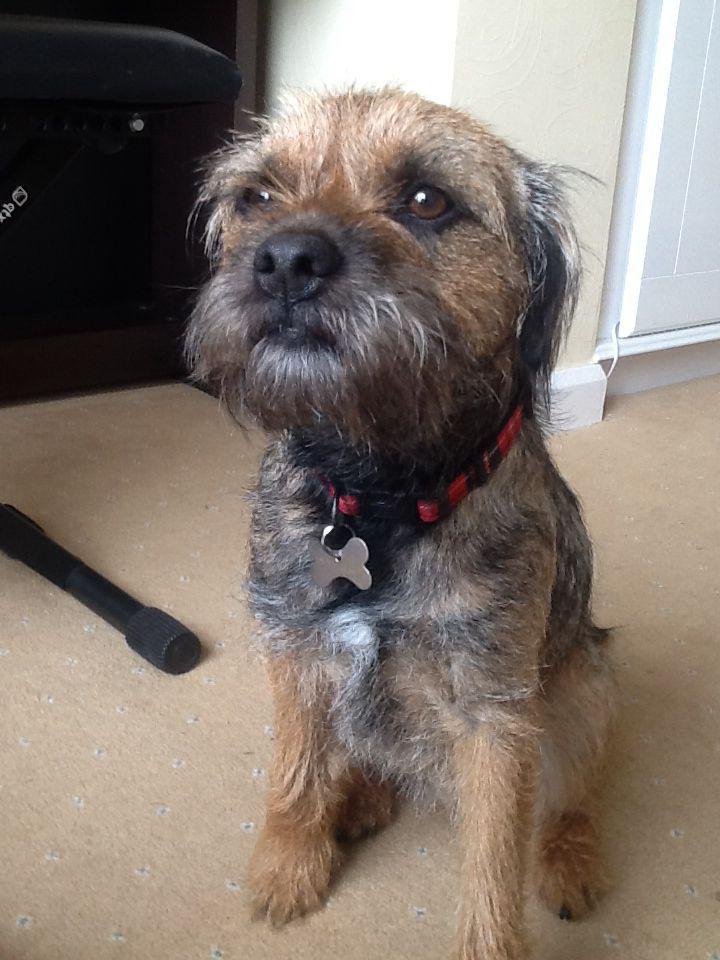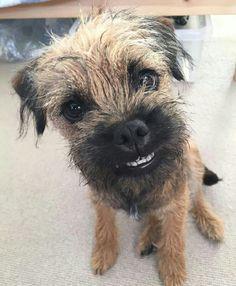The first image is the image on the left, the second image is the image on the right. For the images shown, is this caption "The dog in the image on the left is wearing a red collar." true? Answer yes or no. Yes. The first image is the image on the left, the second image is the image on the right. Assess this claim about the two images: "The dog on the left wears a red collar, and the dog on the right looks forward with a tilted head.". Correct or not? Answer yes or no. Yes. 